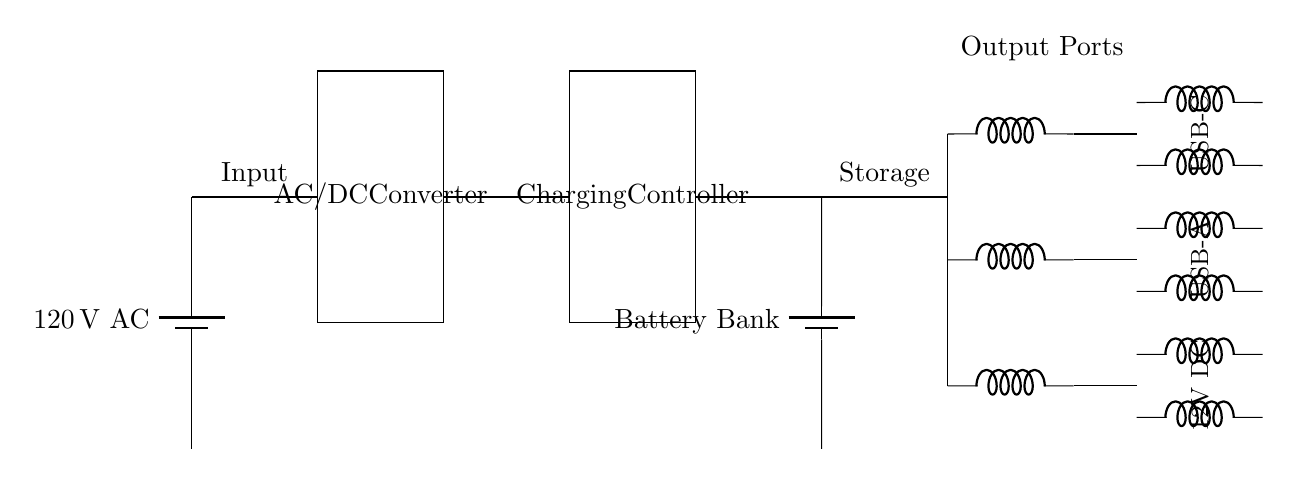What is the input voltage of this circuit? The input voltage is indicated as 120 volts AC, represented by the battery symbol at the top of the circuit diagram.
Answer: 120 volts AC What components are used for output? The output consists of three types of ports: USB-C, USB-A, and 12V DC, as labeled next to the output lines in the circuit diagram.
Answer: USB-C, USB-A, 12V DC How many inductors are there in the output section? The output section has a total of six inductors, with two per each of the three output ports. This can be counted visually from the circuit diagram.
Answer: 6 What is the role of the charging controller? The charging controller regulates the voltage and current going to the battery bank, ensuring efficient charging. Although the label states its function, it does imply active regulation in the circuit.
Answer: Regulate charging What is the voltage supplied to the battery bank? The battery bank is connected directly to the output of the AC/DC converter, meaning it receives the same voltage as specified for the input, which is not explicitly stated but inferred to be 120 volts DC after conversion.
Answer: 120 volts DC Which component converts AC to DC? The AC/DC converter is the component responsible for converting alternating current (AC) from the main power source into direct current (DC) for storage and use in the battery bank.
Answer: AC/DC Converter What is the primary purpose of this circuit? The primary purpose of this circuit is to charge various electronic devices using a battery bank, which is fed through the AC and DC components, particularly for portable charging needs.
Answer: Charge devices 